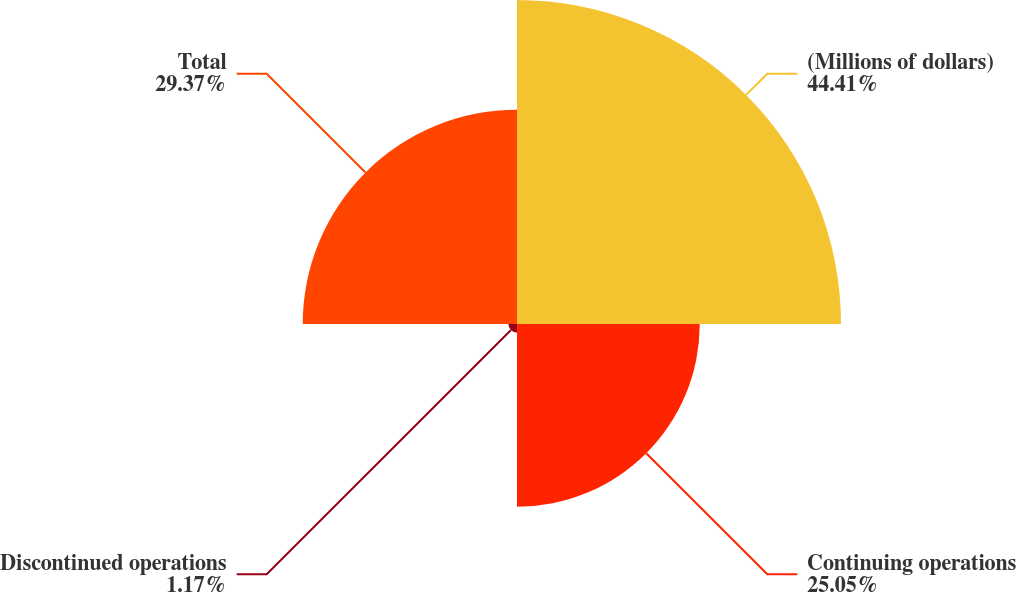Convert chart. <chart><loc_0><loc_0><loc_500><loc_500><pie_chart><fcel>(Millions of dollars)<fcel>Continuing operations<fcel>Discontinued operations<fcel>Total<nl><fcel>44.41%<fcel>25.05%<fcel>1.17%<fcel>29.37%<nl></chart> 